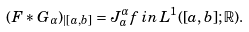<formula> <loc_0><loc_0><loc_500><loc_500>( F * G _ { \alpha } ) _ { | [ a , b ] } = J _ { a } ^ { \alpha } f \, i n \, L ^ { 1 } ( [ a , b ] ; \mathbb { R } ) .</formula> 